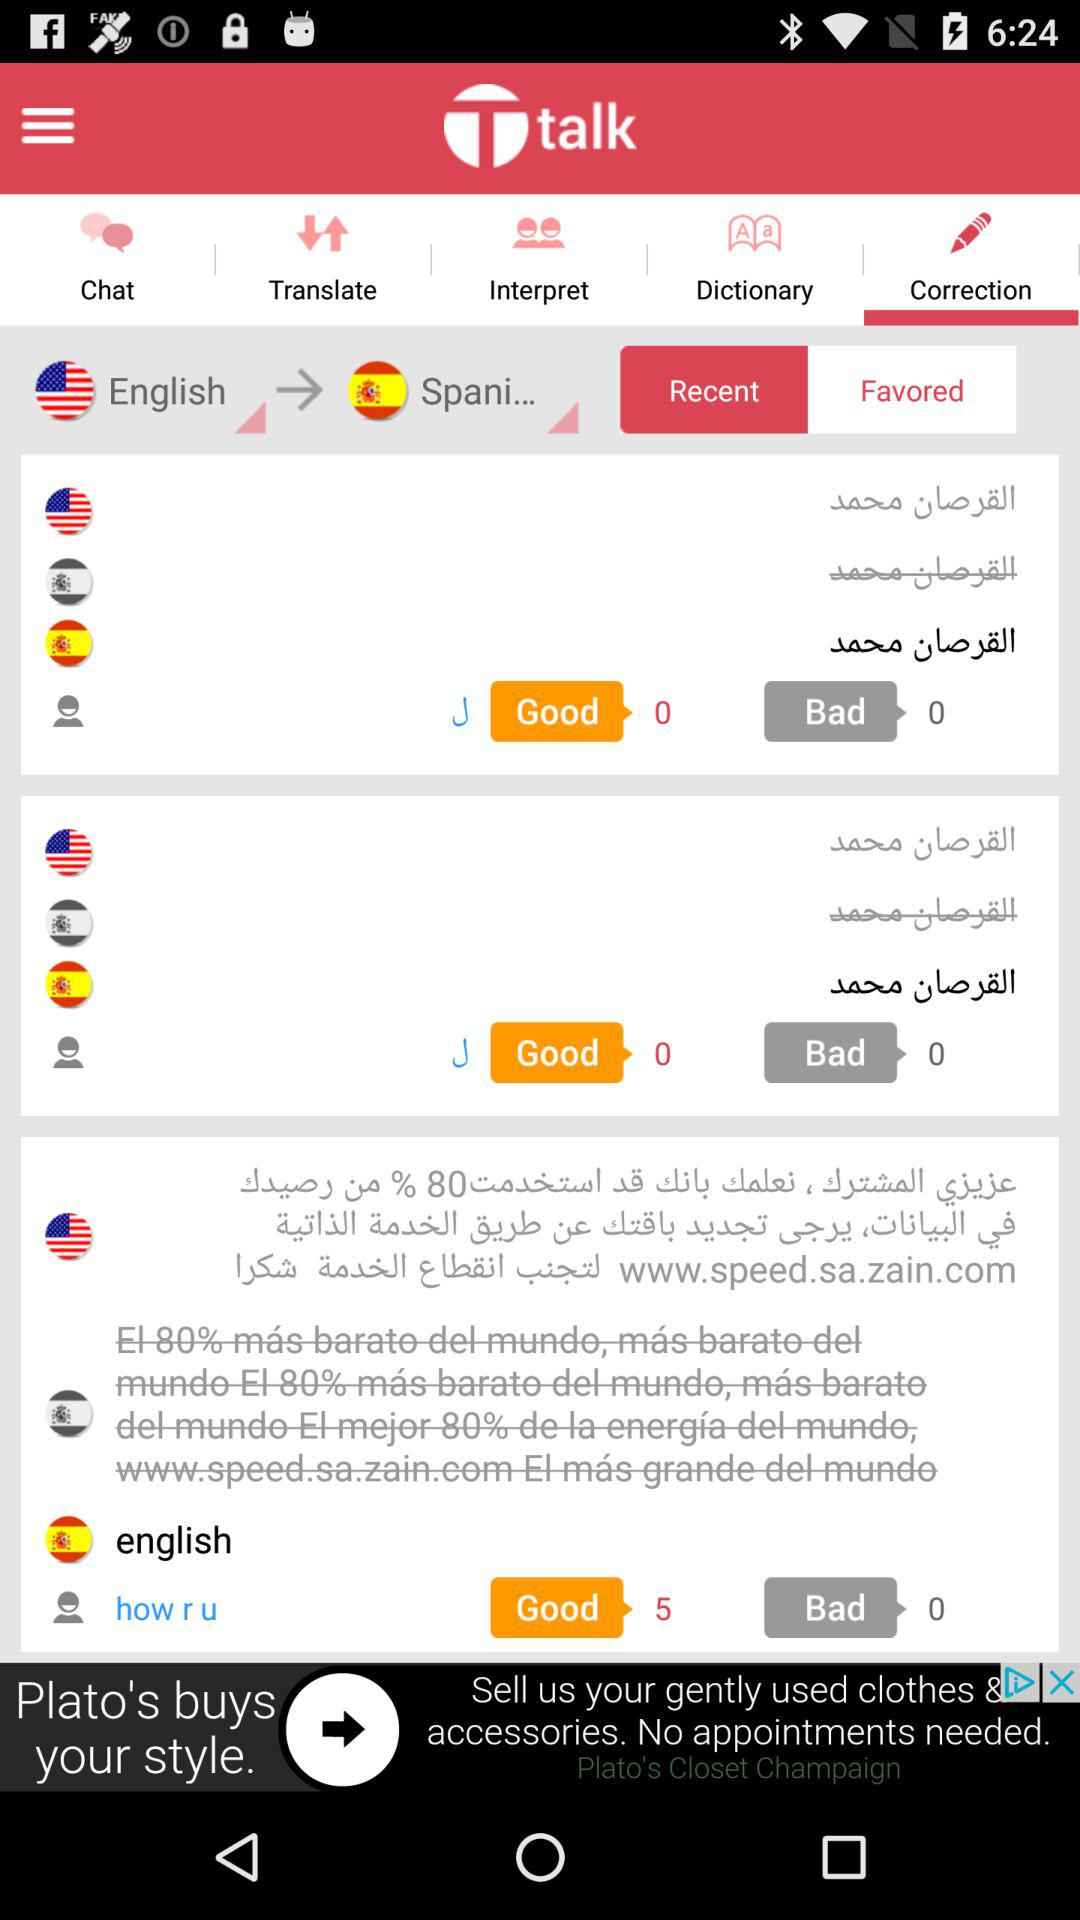What are the available languages? The available languages are English and "Spani...". 